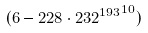Convert formula to latex. <formula><loc_0><loc_0><loc_500><loc_500>( 6 - 2 2 8 \cdot { 2 3 2 ^ { 1 9 3 } } ^ { 1 0 } )</formula> 